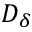<formula> <loc_0><loc_0><loc_500><loc_500>D _ { \delta }</formula> 